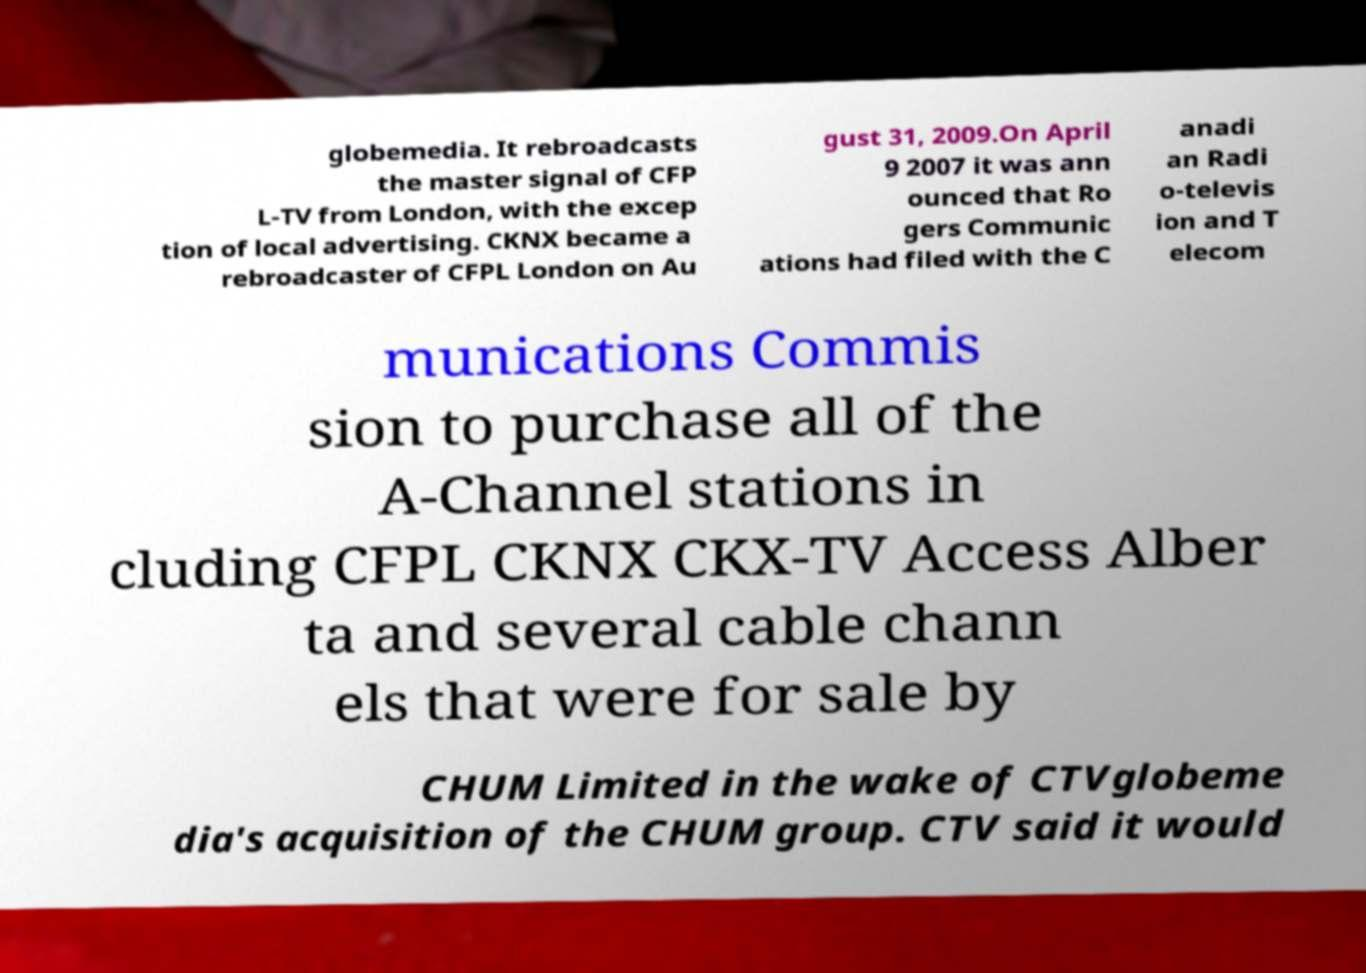Could you extract and type out the text from this image? globemedia. It rebroadcasts the master signal of CFP L-TV from London, with the excep tion of local advertising. CKNX became a rebroadcaster of CFPL London on Au gust 31, 2009.On April 9 2007 it was ann ounced that Ro gers Communic ations had filed with the C anadi an Radi o-televis ion and T elecom munications Commis sion to purchase all of the A-Channel stations in cluding CFPL CKNX CKX-TV Access Alber ta and several cable chann els that were for sale by CHUM Limited in the wake of CTVglobeme dia's acquisition of the CHUM group. CTV said it would 